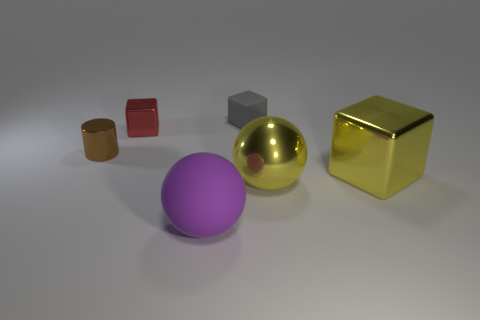Add 3 metal cylinders. How many objects exist? 9 Subtract all cylinders. How many objects are left? 5 Add 3 big rubber balls. How many big rubber balls are left? 4 Add 3 small green rubber cylinders. How many small green rubber cylinders exist? 3 Subtract 0 blue cylinders. How many objects are left? 6 Subtract all green cubes. Subtract all red objects. How many objects are left? 5 